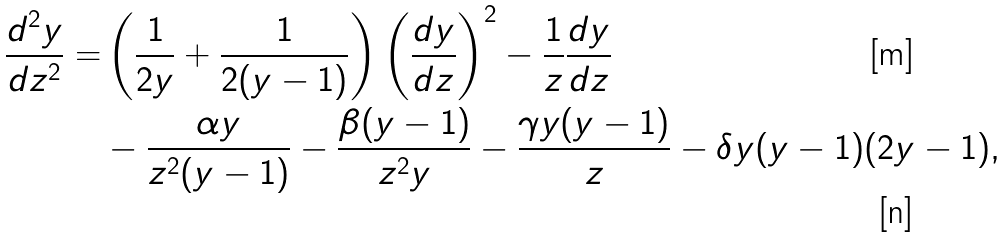Convert formula to latex. <formula><loc_0><loc_0><loc_500><loc_500>\frac { d ^ { 2 } y } { d z ^ { 2 } } = & \left ( \frac { 1 } { 2 y } + \frac { 1 } { 2 ( y - 1 ) } \right ) \left ( \frac { d y } { d z } \right ) ^ { 2 } - \frac { 1 } { z } \frac { d y } { d z } \\ & - \frac { \alpha y } { z ^ { 2 } ( y - 1 ) } - \frac { \beta ( y - 1 ) } { z ^ { 2 } y } - \frac { \gamma y ( y - 1 ) } { z } - \delta y ( y - 1 ) ( 2 y - 1 ) ,</formula> 